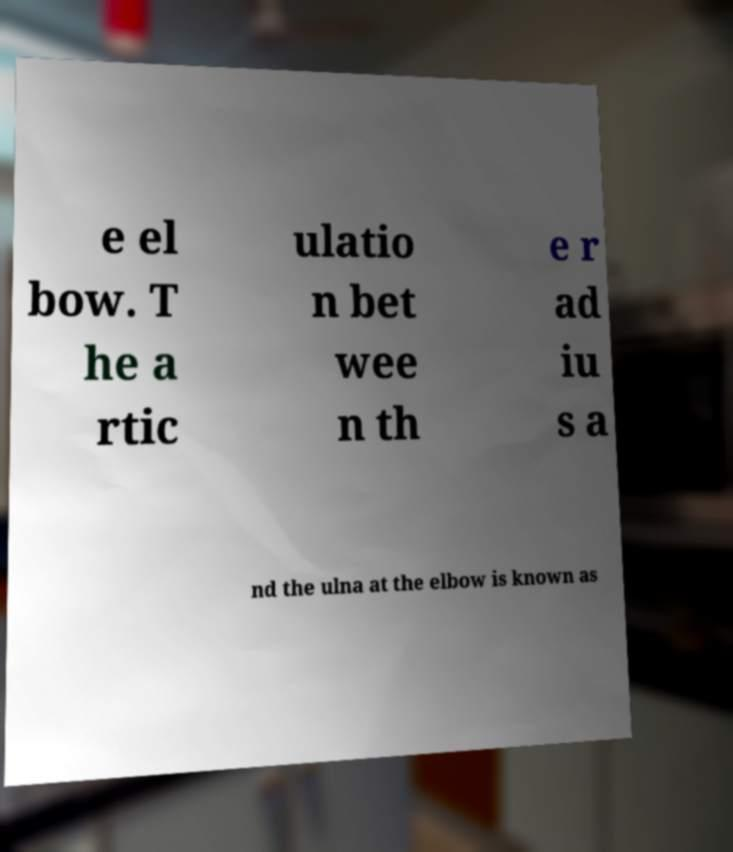Please identify and transcribe the text found in this image. e el bow. T he a rtic ulatio n bet wee n th e r ad iu s a nd the ulna at the elbow is known as 